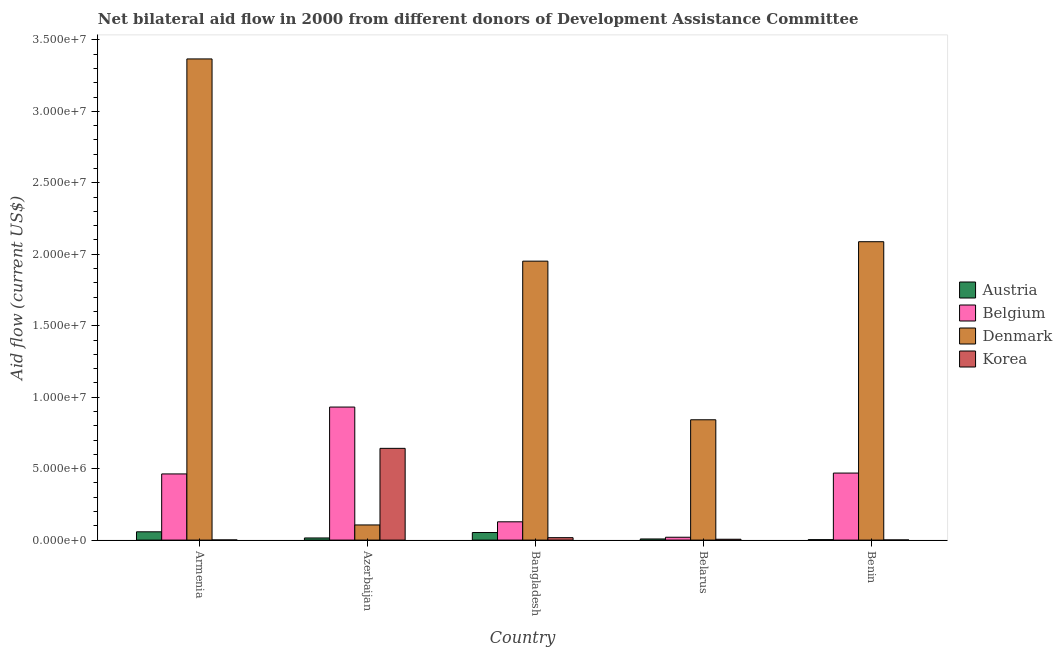How many different coloured bars are there?
Make the answer very short. 4. How many groups of bars are there?
Provide a short and direct response. 5. How many bars are there on the 3rd tick from the left?
Your answer should be very brief. 4. What is the label of the 1st group of bars from the left?
Your answer should be compact. Armenia. In how many cases, is the number of bars for a given country not equal to the number of legend labels?
Your response must be concise. 0. What is the amount of aid given by belgium in Belarus?
Ensure brevity in your answer.  2.00e+05. Across all countries, what is the maximum amount of aid given by denmark?
Your answer should be very brief. 3.37e+07. Across all countries, what is the minimum amount of aid given by denmark?
Your response must be concise. 1.06e+06. In which country was the amount of aid given by austria maximum?
Provide a succinct answer. Armenia. In which country was the amount of aid given by austria minimum?
Provide a short and direct response. Benin. What is the total amount of aid given by belgium in the graph?
Offer a terse response. 2.01e+07. What is the difference between the amount of aid given by belgium in Bangladesh and that in Belarus?
Provide a succinct answer. 1.08e+06. What is the difference between the amount of aid given by denmark in Belarus and the amount of aid given by austria in Azerbaijan?
Offer a terse response. 8.27e+06. What is the average amount of aid given by austria per country?
Your response must be concise. 2.74e+05. What is the difference between the amount of aid given by belgium and amount of aid given by denmark in Belarus?
Provide a short and direct response. -8.22e+06. In how many countries, is the amount of aid given by korea greater than 18000000 US$?
Offer a terse response. 0. Is the amount of aid given by austria in Armenia less than that in Benin?
Your answer should be compact. No. Is the difference between the amount of aid given by belgium in Bangladesh and Benin greater than the difference between the amount of aid given by korea in Bangladesh and Benin?
Give a very brief answer. No. What is the difference between the highest and the second highest amount of aid given by belgium?
Offer a very short reply. 4.62e+06. What is the difference between the highest and the lowest amount of aid given by denmark?
Keep it short and to the point. 3.26e+07. In how many countries, is the amount of aid given by denmark greater than the average amount of aid given by denmark taken over all countries?
Provide a succinct answer. 3. Is the sum of the amount of aid given by austria in Azerbaijan and Bangladesh greater than the maximum amount of aid given by belgium across all countries?
Provide a short and direct response. No. Is it the case that in every country, the sum of the amount of aid given by belgium and amount of aid given by korea is greater than the sum of amount of aid given by austria and amount of aid given by denmark?
Offer a very short reply. Yes. What does the 2nd bar from the left in Bangladesh represents?
Provide a short and direct response. Belgium. What does the 1st bar from the right in Bangladesh represents?
Provide a short and direct response. Korea. Is it the case that in every country, the sum of the amount of aid given by austria and amount of aid given by belgium is greater than the amount of aid given by denmark?
Your answer should be compact. No. Does the graph contain any zero values?
Give a very brief answer. No. How are the legend labels stacked?
Make the answer very short. Vertical. What is the title of the graph?
Your answer should be very brief. Net bilateral aid flow in 2000 from different donors of Development Assistance Committee. What is the label or title of the Y-axis?
Your answer should be very brief. Aid flow (current US$). What is the Aid flow (current US$) of Austria in Armenia?
Ensure brevity in your answer.  5.80e+05. What is the Aid flow (current US$) of Belgium in Armenia?
Make the answer very short. 4.63e+06. What is the Aid flow (current US$) in Denmark in Armenia?
Your answer should be very brief. 3.37e+07. What is the Aid flow (current US$) of Korea in Armenia?
Keep it short and to the point. 10000. What is the Aid flow (current US$) in Austria in Azerbaijan?
Provide a succinct answer. 1.50e+05. What is the Aid flow (current US$) in Belgium in Azerbaijan?
Provide a short and direct response. 9.31e+06. What is the Aid flow (current US$) in Denmark in Azerbaijan?
Provide a succinct answer. 1.06e+06. What is the Aid flow (current US$) in Korea in Azerbaijan?
Offer a very short reply. 6.42e+06. What is the Aid flow (current US$) of Austria in Bangladesh?
Your answer should be very brief. 5.30e+05. What is the Aid flow (current US$) in Belgium in Bangladesh?
Provide a succinct answer. 1.28e+06. What is the Aid flow (current US$) of Denmark in Bangladesh?
Make the answer very short. 1.95e+07. What is the Aid flow (current US$) of Denmark in Belarus?
Your answer should be very brief. 8.42e+06. What is the Aid flow (current US$) of Korea in Belarus?
Offer a terse response. 6.00e+04. What is the Aid flow (current US$) in Belgium in Benin?
Your answer should be very brief. 4.69e+06. What is the Aid flow (current US$) of Denmark in Benin?
Make the answer very short. 2.09e+07. Across all countries, what is the maximum Aid flow (current US$) in Austria?
Ensure brevity in your answer.  5.80e+05. Across all countries, what is the maximum Aid flow (current US$) of Belgium?
Your answer should be compact. 9.31e+06. Across all countries, what is the maximum Aid flow (current US$) of Denmark?
Ensure brevity in your answer.  3.37e+07. Across all countries, what is the maximum Aid flow (current US$) of Korea?
Provide a short and direct response. 6.42e+06. Across all countries, what is the minimum Aid flow (current US$) of Austria?
Your response must be concise. 3.00e+04. Across all countries, what is the minimum Aid flow (current US$) of Belgium?
Provide a succinct answer. 2.00e+05. Across all countries, what is the minimum Aid flow (current US$) of Denmark?
Make the answer very short. 1.06e+06. What is the total Aid flow (current US$) of Austria in the graph?
Your response must be concise. 1.37e+06. What is the total Aid flow (current US$) in Belgium in the graph?
Your answer should be very brief. 2.01e+07. What is the total Aid flow (current US$) in Denmark in the graph?
Keep it short and to the point. 8.36e+07. What is the total Aid flow (current US$) of Korea in the graph?
Your response must be concise. 6.67e+06. What is the difference between the Aid flow (current US$) in Austria in Armenia and that in Azerbaijan?
Keep it short and to the point. 4.30e+05. What is the difference between the Aid flow (current US$) in Belgium in Armenia and that in Azerbaijan?
Your answer should be compact. -4.68e+06. What is the difference between the Aid flow (current US$) in Denmark in Armenia and that in Azerbaijan?
Keep it short and to the point. 3.26e+07. What is the difference between the Aid flow (current US$) in Korea in Armenia and that in Azerbaijan?
Keep it short and to the point. -6.41e+06. What is the difference between the Aid flow (current US$) of Austria in Armenia and that in Bangladesh?
Provide a succinct answer. 5.00e+04. What is the difference between the Aid flow (current US$) of Belgium in Armenia and that in Bangladesh?
Offer a very short reply. 3.35e+06. What is the difference between the Aid flow (current US$) of Denmark in Armenia and that in Bangladesh?
Your answer should be compact. 1.42e+07. What is the difference between the Aid flow (current US$) of Korea in Armenia and that in Bangladesh?
Keep it short and to the point. -1.60e+05. What is the difference between the Aid flow (current US$) in Belgium in Armenia and that in Belarus?
Your answer should be very brief. 4.43e+06. What is the difference between the Aid flow (current US$) in Denmark in Armenia and that in Belarus?
Give a very brief answer. 2.52e+07. What is the difference between the Aid flow (current US$) in Korea in Armenia and that in Belarus?
Your answer should be very brief. -5.00e+04. What is the difference between the Aid flow (current US$) of Belgium in Armenia and that in Benin?
Your answer should be very brief. -6.00e+04. What is the difference between the Aid flow (current US$) of Denmark in Armenia and that in Benin?
Provide a short and direct response. 1.28e+07. What is the difference between the Aid flow (current US$) of Korea in Armenia and that in Benin?
Give a very brief answer. 0. What is the difference between the Aid flow (current US$) in Austria in Azerbaijan and that in Bangladesh?
Your answer should be very brief. -3.80e+05. What is the difference between the Aid flow (current US$) of Belgium in Azerbaijan and that in Bangladesh?
Offer a very short reply. 8.03e+06. What is the difference between the Aid flow (current US$) in Denmark in Azerbaijan and that in Bangladesh?
Give a very brief answer. -1.85e+07. What is the difference between the Aid flow (current US$) of Korea in Azerbaijan and that in Bangladesh?
Offer a very short reply. 6.25e+06. What is the difference between the Aid flow (current US$) of Belgium in Azerbaijan and that in Belarus?
Keep it short and to the point. 9.11e+06. What is the difference between the Aid flow (current US$) of Denmark in Azerbaijan and that in Belarus?
Ensure brevity in your answer.  -7.36e+06. What is the difference between the Aid flow (current US$) of Korea in Azerbaijan and that in Belarus?
Your answer should be compact. 6.36e+06. What is the difference between the Aid flow (current US$) of Austria in Azerbaijan and that in Benin?
Provide a succinct answer. 1.20e+05. What is the difference between the Aid flow (current US$) of Belgium in Azerbaijan and that in Benin?
Offer a terse response. 4.62e+06. What is the difference between the Aid flow (current US$) of Denmark in Azerbaijan and that in Benin?
Provide a short and direct response. -1.98e+07. What is the difference between the Aid flow (current US$) in Korea in Azerbaijan and that in Benin?
Your response must be concise. 6.41e+06. What is the difference between the Aid flow (current US$) in Austria in Bangladesh and that in Belarus?
Give a very brief answer. 4.50e+05. What is the difference between the Aid flow (current US$) in Belgium in Bangladesh and that in Belarus?
Your response must be concise. 1.08e+06. What is the difference between the Aid flow (current US$) of Denmark in Bangladesh and that in Belarus?
Offer a very short reply. 1.11e+07. What is the difference between the Aid flow (current US$) in Belgium in Bangladesh and that in Benin?
Offer a very short reply. -3.41e+06. What is the difference between the Aid flow (current US$) in Denmark in Bangladesh and that in Benin?
Provide a short and direct response. -1.36e+06. What is the difference between the Aid flow (current US$) of Korea in Bangladesh and that in Benin?
Offer a very short reply. 1.60e+05. What is the difference between the Aid flow (current US$) of Austria in Belarus and that in Benin?
Your answer should be very brief. 5.00e+04. What is the difference between the Aid flow (current US$) of Belgium in Belarus and that in Benin?
Your answer should be very brief. -4.49e+06. What is the difference between the Aid flow (current US$) in Denmark in Belarus and that in Benin?
Your response must be concise. -1.25e+07. What is the difference between the Aid flow (current US$) of Austria in Armenia and the Aid flow (current US$) of Belgium in Azerbaijan?
Keep it short and to the point. -8.73e+06. What is the difference between the Aid flow (current US$) in Austria in Armenia and the Aid flow (current US$) in Denmark in Azerbaijan?
Keep it short and to the point. -4.80e+05. What is the difference between the Aid flow (current US$) in Austria in Armenia and the Aid flow (current US$) in Korea in Azerbaijan?
Your response must be concise. -5.84e+06. What is the difference between the Aid flow (current US$) in Belgium in Armenia and the Aid flow (current US$) in Denmark in Azerbaijan?
Give a very brief answer. 3.57e+06. What is the difference between the Aid flow (current US$) in Belgium in Armenia and the Aid flow (current US$) in Korea in Azerbaijan?
Keep it short and to the point. -1.79e+06. What is the difference between the Aid flow (current US$) in Denmark in Armenia and the Aid flow (current US$) in Korea in Azerbaijan?
Your answer should be compact. 2.72e+07. What is the difference between the Aid flow (current US$) of Austria in Armenia and the Aid flow (current US$) of Belgium in Bangladesh?
Keep it short and to the point. -7.00e+05. What is the difference between the Aid flow (current US$) in Austria in Armenia and the Aid flow (current US$) in Denmark in Bangladesh?
Provide a succinct answer. -1.89e+07. What is the difference between the Aid flow (current US$) in Austria in Armenia and the Aid flow (current US$) in Korea in Bangladesh?
Ensure brevity in your answer.  4.10e+05. What is the difference between the Aid flow (current US$) of Belgium in Armenia and the Aid flow (current US$) of Denmark in Bangladesh?
Ensure brevity in your answer.  -1.49e+07. What is the difference between the Aid flow (current US$) of Belgium in Armenia and the Aid flow (current US$) of Korea in Bangladesh?
Offer a terse response. 4.46e+06. What is the difference between the Aid flow (current US$) of Denmark in Armenia and the Aid flow (current US$) of Korea in Bangladesh?
Provide a short and direct response. 3.35e+07. What is the difference between the Aid flow (current US$) of Austria in Armenia and the Aid flow (current US$) of Belgium in Belarus?
Provide a succinct answer. 3.80e+05. What is the difference between the Aid flow (current US$) in Austria in Armenia and the Aid flow (current US$) in Denmark in Belarus?
Provide a succinct answer. -7.84e+06. What is the difference between the Aid flow (current US$) in Austria in Armenia and the Aid flow (current US$) in Korea in Belarus?
Your response must be concise. 5.20e+05. What is the difference between the Aid flow (current US$) of Belgium in Armenia and the Aid flow (current US$) of Denmark in Belarus?
Make the answer very short. -3.79e+06. What is the difference between the Aid flow (current US$) in Belgium in Armenia and the Aid flow (current US$) in Korea in Belarus?
Your response must be concise. 4.57e+06. What is the difference between the Aid flow (current US$) in Denmark in Armenia and the Aid flow (current US$) in Korea in Belarus?
Give a very brief answer. 3.36e+07. What is the difference between the Aid flow (current US$) of Austria in Armenia and the Aid flow (current US$) of Belgium in Benin?
Give a very brief answer. -4.11e+06. What is the difference between the Aid flow (current US$) of Austria in Armenia and the Aid flow (current US$) of Denmark in Benin?
Provide a succinct answer. -2.03e+07. What is the difference between the Aid flow (current US$) in Austria in Armenia and the Aid flow (current US$) in Korea in Benin?
Provide a short and direct response. 5.70e+05. What is the difference between the Aid flow (current US$) of Belgium in Armenia and the Aid flow (current US$) of Denmark in Benin?
Make the answer very short. -1.62e+07. What is the difference between the Aid flow (current US$) of Belgium in Armenia and the Aid flow (current US$) of Korea in Benin?
Your answer should be compact. 4.62e+06. What is the difference between the Aid flow (current US$) in Denmark in Armenia and the Aid flow (current US$) in Korea in Benin?
Provide a succinct answer. 3.37e+07. What is the difference between the Aid flow (current US$) in Austria in Azerbaijan and the Aid flow (current US$) in Belgium in Bangladesh?
Offer a very short reply. -1.13e+06. What is the difference between the Aid flow (current US$) in Austria in Azerbaijan and the Aid flow (current US$) in Denmark in Bangladesh?
Provide a succinct answer. -1.94e+07. What is the difference between the Aid flow (current US$) in Belgium in Azerbaijan and the Aid flow (current US$) in Denmark in Bangladesh?
Your answer should be very brief. -1.02e+07. What is the difference between the Aid flow (current US$) in Belgium in Azerbaijan and the Aid flow (current US$) in Korea in Bangladesh?
Your answer should be very brief. 9.14e+06. What is the difference between the Aid flow (current US$) in Denmark in Azerbaijan and the Aid flow (current US$) in Korea in Bangladesh?
Offer a terse response. 8.90e+05. What is the difference between the Aid flow (current US$) of Austria in Azerbaijan and the Aid flow (current US$) of Belgium in Belarus?
Offer a very short reply. -5.00e+04. What is the difference between the Aid flow (current US$) of Austria in Azerbaijan and the Aid flow (current US$) of Denmark in Belarus?
Make the answer very short. -8.27e+06. What is the difference between the Aid flow (current US$) in Austria in Azerbaijan and the Aid flow (current US$) in Korea in Belarus?
Keep it short and to the point. 9.00e+04. What is the difference between the Aid flow (current US$) in Belgium in Azerbaijan and the Aid flow (current US$) in Denmark in Belarus?
Keep it short and to the point. 8.90e+05. What is the difference between the Aid flow (current US$) of Belgium in Azerbaijan and the Aid flow (current US$) of Korea in Belarus?
Your answer should be very brief. 9.25e+06. What is the difference between the Aid flow (current US$) of Austria in Azerbaijan and the Aid flow (current US$) of Belgium in Benin?
Offer a terse response. -4.54e+06. What is the difference between the Aid flow (current US$) of Austria in Azerbaijan and the Aid flow (current US$) of Denmark in Benin?
Your response must be concise. -2.07e+07. What is the difference between the Aid flow (current US$) in Belgium in Azerbaijan and the Aid flow (current US$) in Denmark in Benin?
Make the answer very short. -1.16e+07. What is the difference between the Aid flow (current US$) in Belgium in Azerbaijan and the Aid flow (current US$) in Korea in Benin?
Offer a very short reply. 9.30e+06. What is the difference between the Aid flow (current US$) of Denmark in Azerbaijan and the Aid flow (current US$) of Korea in Benin?
Offer a very short reply. 1.05e+06. What is the difference between the Aid flow (current US$) of Austria in Bangladesh and the Aid flow (current US$) of Belgium in Belarus?
Provide a short and direct response. 3.30e+05. What is the difference between the Aid flow (current US$) of Austria in Bangladesh and the Aid flow (current US$) of Denmark in Belarus?
Your response must be concise. -7.89e+06. What is the difference between the Aid flow (current US$) in Austria in Bangladesh and the Aid flow (current US$) in Korea in Belarus?
Your answer should be very brief. 4.70e+05. What is the difference between the Aid flow (current US$) in Belgium in Bangladesh and the Aid flow (current US$) in Denmark in Belarus?
Keep it short and to the point. -7.14e+06. What is the difference between the Aid flow (current US$) in Belgium in Bangladesh and the Aid flow (current US$) in Korea in Belarus?
Give a very brief answer. 1.22e+06. What is the difference between the Aid flow (current US$) in Denmark in Bangladesh and the Aid flow (current US$) in Korea in Belarus?
Offer a terse response. 1.95e+07. What is the difference between the Aid flow (current US$) of Austria in Bangladesh and the Aid flow (current US$) of Belgium in Benin?
Make the answer very short. -4.16e+06. What is the difference between the Aid flow (current US$) in Austria in Bangladesh and the Aid flow (current US$) in Denmark in Benin?
Keep it short and to the point. -2.04e+07. What is the difference between the Aid flow (current US$) in Austria in Bangladesh and the Aid flow (current US$) in Korea in Benin?
Keep it short and to the point. 5.20e+05. What is the difference between the Aid flow (current US$) in Belgium in Bangladesh and the Aid flow (current US$) in Denmark in Benin?
Give a very brief answer. -1.96e+07. What is the difference between the Aid flow (current US$) of Belgium in Bangladesh and the Aid flow (current US$) of Korea in Benin?
Provide a succinct answer. 1.27e+06. What is the difference between the Aid flow (current US$) in Denmark in Bangladesh and the Aid flow (current US$) in Korea in Benin?
Your answer should be very brief. 1.95e+07. What is the difference between the Aid flow (current US$) in Austria in Belarus and the Aid flow (current US$) in Belgium in Benin?
Offer a very short reply. -4.61e+06. What is the difference between the Aid flow (current US$) in Austria in Belarus and the Aid flow (current US$) in Denmark in Benin?
Provide a short and direct response. -2.08e+07. What is the difference between the Aid flow (current US$) in Austria in Belarus and the Aid flow (current US$) in Korea in Benin?
Offer a very short reply. 7.00e+04. What is the difference between the Aid flow (current US$) of Belgium in Belarus and the Aid flow (current US$) of Denmark in Benin?
Keep it short and to the point. -2.07e+07. What is the difference between the Aid flow (current US$) of Belgium in Belarus and the Aid flow (current US$) of Korea in Benin?
Give a very brief answer. 1.90e+05. What is the difference between the Aid flow (current US$) in Denmark in Belarus and the Aid flow (current US$) in Korea in Benin?
Your answer should be very brief. 8.41e+06. What is the average Aid flow (current US$) in Austria per country?
Provide a short and direct response. 2.74e+05. What is the average Aid flow (current US$) in Belgium per country?
Make the answer very short. 4.02e+06. What is the average Aid flow (current US$) in Denmark per country?
Your response must be concise. 1.67e+07. What is the average Aid flow (current US$) in Korea per country?
Ensure brevity in your answer.  1.33e+06. What is the difference between the Aid flow (current US$) in Austria and Aid flow (current US$) in Belgium in Armenia?
Ensure brevity in your answer.  -4.05e+06. What is the difference between the Aid flow (current US$) in Austria and Aid flow (current US$) in Denmark in Armenia?
Provide a succinct answer. -3.31e+07. What is the difference between the Aid flow (current US$) in Austria and Aid flow (current US$) in Korea in Armenia?
Provide a succinct answer. 5.70e+05. What is the difference between the Aid flow (current US$) of Belgium and Aid flow (current US$) of Denmark in Armenia?
Provide a succinct answer. -2.90e+07. What is the difference between the Aid flow (current US$) of Belgium and Aid flow (current US$) of Korea in Armenia?
Your answer should be compact. 4.62e+06. What is the difference between the Aid flow (current US$) in Denmark and Aid flow (current US$) in Korea in Armenia?
Provide a succinct answer. 3.37e+07. What is the difference between the Aid flow (current US$) of Austria and Aid flow (current US$) of Belgium in Azerbaijan?
Make the answer very short. -9.16e+06. What is the difference between the Aid flow (current US$) in Austria and Aid flow (current US$) in Denmark in Azerbaijan?
Provide a succinct answer. -9.10e+05. What is the difference between the Aid flow (current US$) in Austria and Aid flow (current US$) in Korea in Azerbaijan?
Offer a terse response. -6.27e+06. What is the difference between the Aid flow (current US$) of Belgium and Aid flow (current US$) of Denmark in Azerbaijan?
Your answer should be very brief. 8.25e+06. What is the difference between the Aid flow (current US$) in Belgium and Aid flow (current US$) in Korea in Azerbaijan?
Provide a succinct answer. 2.89e+06. What is the difference between the Aid flow (current US$) in Denmark and Aid flow (current US$) in Korea in Azerbaijan?
Your answer should be very brief. -5.36e+06. What is the difference between the Aid flow (current US$) of Austria and Aid flow (current US$) of Belgium in Bangladesh?
Your answer should be compact. -7.50e+05. What is the difference between the Aid flow (current US$) of Austria and Aid flow (current US$) of Denmark in Bangladesh?
Your answer should be compact. -1.90e+07. What is the difference between the Aid flow (current US$) of Austria and Aid flow (current US$) of Korea in Bangladesh?
Make the answer very short. 3.60e+05. What is the difference between the Aid flow (current US$) of Belgium and Aid flow (current US$) of Denmark in Bangladesh?
Provide a succinct answer. -1.82e+07. What is the difference between the Aid flow (current US$) in Belgium and Aid flow (current US$) in Korea in Bangladesh?
Ensure brevity in your answer.  1.11e+06. What is the difference between the Aid flow (current US$) in Denmark and Aid flow (current US$) in Korea in Bangladesh?
Your response must be concise. 1.94e+07. What is the difference between the Aid flow (current US$) of Austria and Aid flow (current US$) of Denmark in Belarus?
Provide a short and direct response. -8.34e+06. What is the difference between the Aid flow (current US$) of Austria and Aid flow (current US$) of Korea in Belarus?
Your answer should be compact. 2.00e+04. What is the difference between the Aid flow (current US$) in Belgium and Aid flow (current US$) in Denmark in Belarus?
Your answer should be very brief. -8.22e+06. What is the difference between the Aid flow (current US$) in Belgium and Aid flow (current US$) in Korea in Belarus?
Your answer should be compact. 1.40e+05. What is the difference between the Aid flow (current US$) in Denmark and Aid flow (current US$) in Korea in Belarus?
Keep it short and to the point. 8.36e+06. What is the difference between the Aid flow (current US$) in Austria and Aid flow (current US$) in Belgium in Benin?
Provide a short and direct response. -4.66e+06. What is the difference between the Aid flow (current US$) of Austria and Aid flow (current US$) of Denmark in Benin?
Give a very brief answer. -2.08e+07. What is the difference between the Aid flow (current US$) in Austria and Aid flow (current US$) in Korea in Benin?
Your answer should be very brief. 2.00e+04. What is the difference between the Aid flow (current US$) in Belgium and Aid flow (current US$) in Denmark in Benin?
Your answer should be very brief. -1.62e+07. What is the difference between the Aid flow (current US$) of Belgium and Aid flow (current US$) of Korea in Benin?
Your response must be concise. 4.68e+06. What is the difference between the Aid flow (current US$) of Denmark and Aid flow (current US$) of Korea in Benin?
Your answer should be compact. 2.09e+07. What is the ratio of the Aid flow (current US$) in Austria in Armenia to that in Azerbaijan?
Provide a short and direct response. 3.87. What is the ratio of the Aid flow (current US$) of Belgium in Armenia to that in Azerbaijan?
Offer a terse response. 0.5. What is the ratio of the Aid flow (current US$) of Denmark in Armenia to that in Azerbaijan?
Your response must be concise. 31.76. What is the ratio of the Aid flow (current US$) of Korea in Armenia to that in Azerbaijan?
Ensure brevity in your answer.  0. What is the ratio of the Aid flow (current US$) of Austria in Armenia to that in Bangladesh?
Offer a terse response. 1.09. What is the ratio of the Aid flow (current US$) of Belgium in Armenia to that in Bangladesh?
Offer a terse response. 3.62. What is the ratio of the Aid flow (current US$) in Denmark in Armenia to that in Bangladesh?
Your answer should be compact. 1.72. What is the ratio of the Aid flow (current US$) of Korea in Armenia to that in Bangladesh?
Provide a short and direct response. 0.06. What is the ratio of the Aid flow (current US$) of Austria in Armenia to that in Belarus?
Your response must be concise. 7.25. What is the ratio of the Aid flow (current US$) of Belgium in Armenia to that in Belarus?
Your answer should be very brief. 23.15. What is the ratio of the Aid flow (current US$) in Denmark in Armenia to that in Belarus?
Give a very brief answer. 4. What is the ratio of the Aid flow (current US$) of Korea in Armenia to that in Belarus?
Offer a very short reply. 0.17. What is the ratio of the Aid flow (current US$) in Austria in Armenia to that in Benin?
Your answer should be compact. 19.33. What is the ratio of the Aid flow (current US$) in Belgium in Armenia to that in Benin?
Offer a terse response. 0.99. What is the ratio of the Aid flow (current US$) of Denmark in Armenia to that in Benin?
Offer a very short reply. 1.61. What is the ratio of the Aid flow (current US$) of Austria in Azerbaijan to that in Bangladesh?
Make the answer very short. 0.28. What is the ratio of the Aid flow (current US$) in Belgium in Azerbaijan to that in Bangladesh?
Your response must be concise. 7.27. What is the ratio of the Aid flow (current US$) in Denmark in Azerbaijan to that in Bangladesh?
Give a very brief answer. 0.05. What is the ratio of the Aid flow (current US$) in Korea in Azerbaijan to that in Bangladesh?
Ensure brevity in your answer.  37.76. What is the ratio of the Aid flow (current US$) of Austria in Azerbaijan to that in Belarus?
Your answer should be very brief. 1.88. What is the ratio of the Aid flow (current US$) of Belgium in Azerbaijan to that in Belarus?
Your answer should be compact. 46.55. What is the ratio of the Aid flow (current US$) of Denmark in Azerbaijan to that in Belarus?
Keep it short and to the point. 0.13. What is the ratio of the Aid flow (current US$) of Korea in Azerbaijan to that in Belarus?
Your answer should be very brief. 107. What is the ratio of the Aid flow (current US$) of Austria in Azerbaijan to that in Benin?
Provide a succinct answer. 5. What is the ratio of the Aid flow (current US$) in Belgium in Azerbaijan to that in Benin?
Keep it short and to the point. 1.99. What is the ratio of the Aid flow (current US$) of Denmark in Azerbaijan to that in Benin?
Make the answer very short. 0.05. What is the ratio of the Aid flow (current US$) of Korea in Azerbaijan to that in Benin?
Keep it short and to the point. 642. What is the ratio of the Aid flow (current US$) in Austria in Bangladesh to that in Belarus?
Your response must be concise. 6.62. What is the ratio of the Aid flow (current US$) of Denmark in Bangladesh to that in Belarus?
Ensure brevity in your answer.  2.32. What is the ratio of the Aid flow (current US$) in Korea in Bangladesh to that in Belarus?
Ensure brevity in your answer.  2.83. What is the ratio of the Aid flow (current US$) of Austria in Bangladesh to that in Benin?
Your answer should be compact. 17.67. What is the ratio of the Aid flow (current US$) in Belgium in Bangladesh to that in Benin?
Your answer should be compact. 0.27. What is the ratio of the Aid flow (current US$) of Denmark in Bangladesh to that in Benin?
Make the answer very short. 0.93. What is the ratio of the Aid flow (current US$) of Austria in Belarus to that in Benin?
Offer a very short reply. 2.67. What is the ratio of the Aid flow (current US$) of Belgium in Belarus to that in Benin?
Offer a terse response. 0.04. What is the ratio of the Aid flow (current US$) in Denmark in Belarus to that in Benin?
Keep it short and to the point. 0.4. What is the ratio of the Aid flow (current US$) of Korea in Belarus to that in Benin?
Make the answer very short. 6. What is the difference between the highest and the second highest Aid flow (current US$) of Belgium?
Your response must be concise. 4.62e+06. What is the difference between the highest and the second highest Aid flow (current US$) in Denmark?
Keep it short and to the point. 1.28e+07. What is the difference between the highest and the second highest Aid flow (current US$) in Korea?
Your response must be concise. 6.25e+06. What is the difference between the highest and the lowest Aid flow (current US$) in Austria?
Make the answer very short. 5.50e+05. What is the difference between the highest and the lowest Aid flow (current US$) of Belgium?
Offer a terse response. 9.11e+06. What is the difference between the highest and the lowest Aid flow (current US$) in Denmark?
Keep it short and to the point. 3.26e+07. What is the difference between the highest and the lowest Aid flow (current US$) of Korea?
Give a very brief answer. 6.41e+06. 